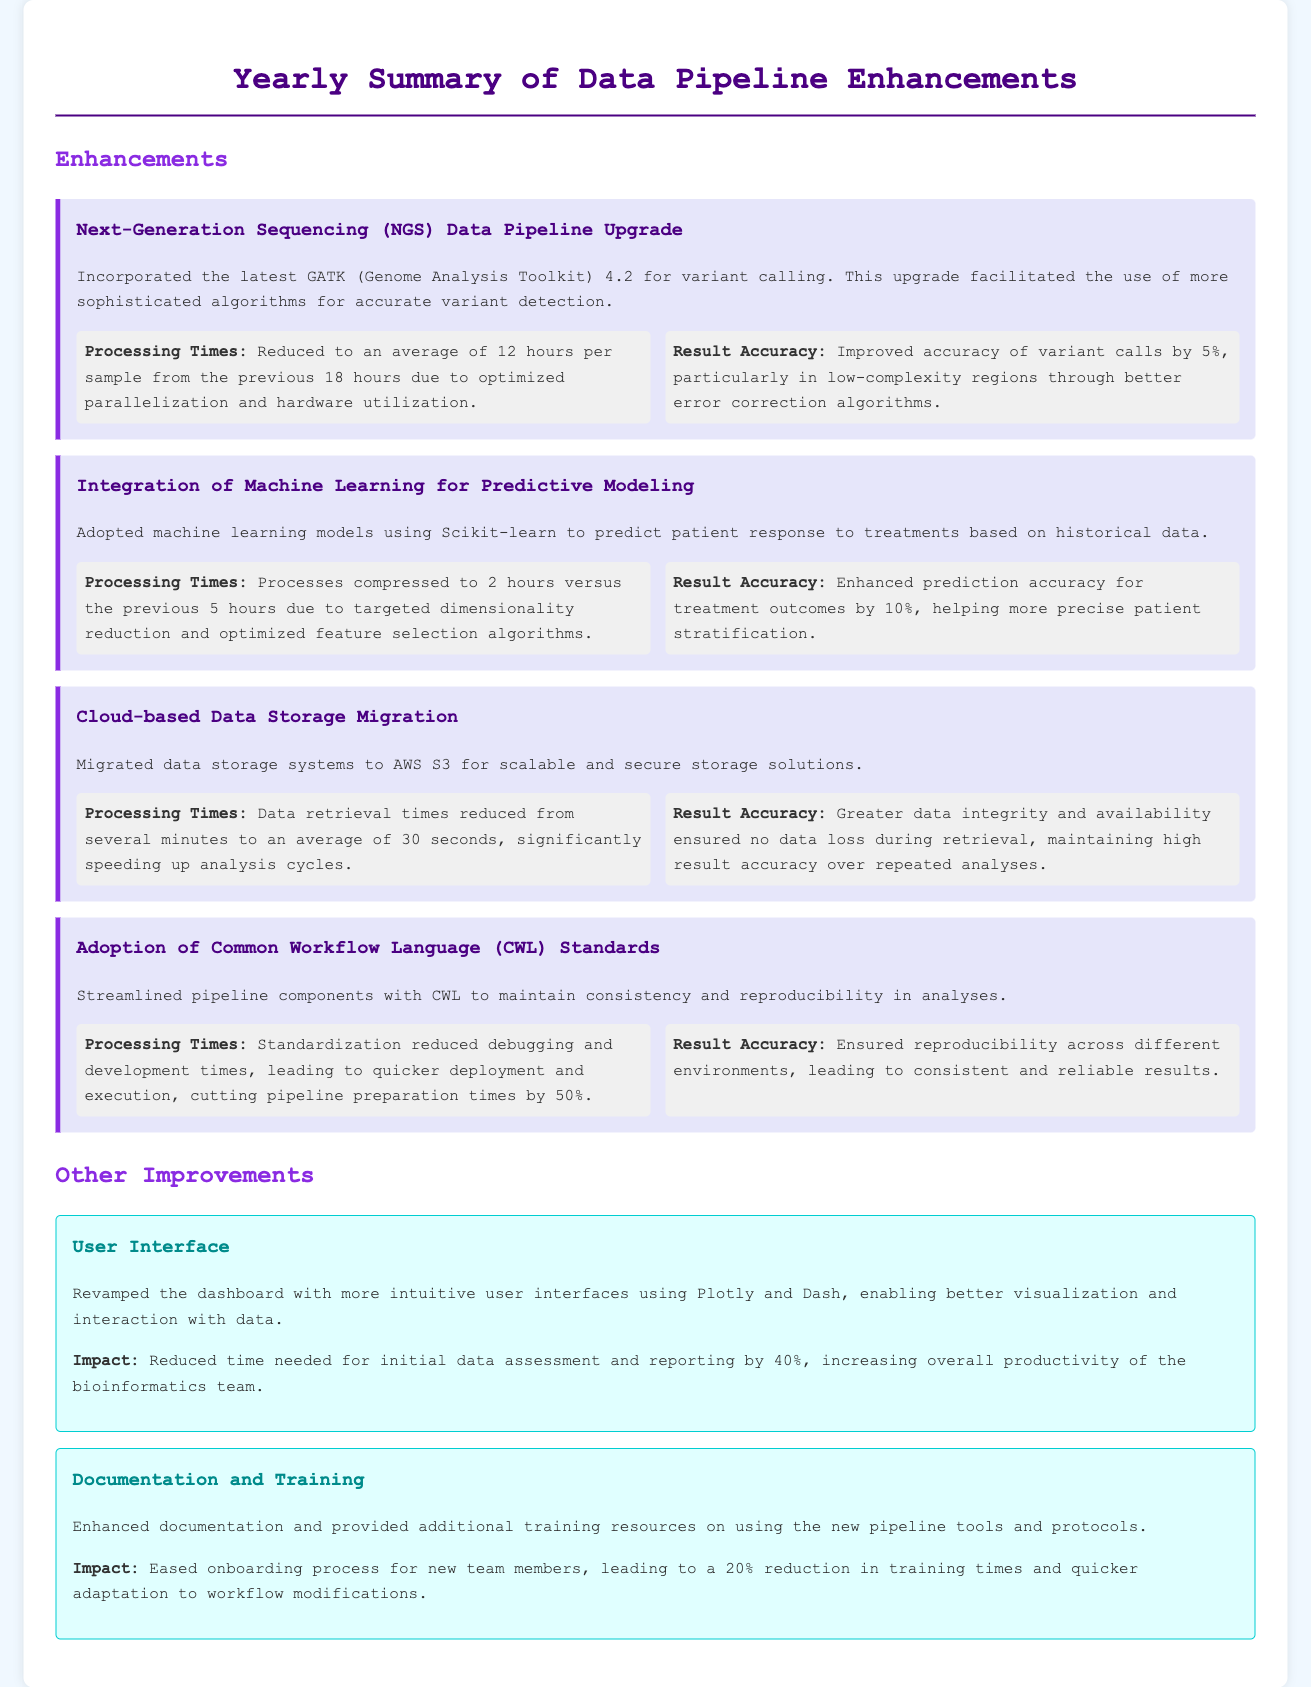What is the average processing time after the NGS upgrade? The average processing time after the upgrade was reduced to 12 hours per sample.
Answer: 12 hours By how much did the integration of machine learning improve the prediction accuracy? The integration of machine learning improved prediction accuracy for treatment outcomes by 10%.
Answer: 10% What was the retrieval time for data after the migration to cloud storage? After the migration, data retrieval times were reduced to an average of 30 seconds.
Answer: 30 seconds What technology was adopted to ensure reproducibility in analyses? The Common Workflow Language (CWL) standards were adopted for reproducibility.
Answer: CWL How much was the time needed for initial data assessment reduced by the user interface improvement? The time needed for initial data assessment and reporting was reduced by 40%.
Answer: 40% What was the impact of enhanced documentation and training on training times? Enhanced documentation and training led to a 20% reduction in training times.
Answer: 20% What was the previous processing time for the machine learning predictive modeling before the enhancements? The previous processing time was 5 hours before the enhancements.
Answer: 5 hours Which toolkit version was incorporated in the NGS data pipeline upgrade? The version incorporated was GATK 4.2.
Answer: GATK 4.2 What is mentioned as the main benefit of adopting CWL standards? The main benefit is ensuring reproducibility across different environments.
Answer: Reproducibility 